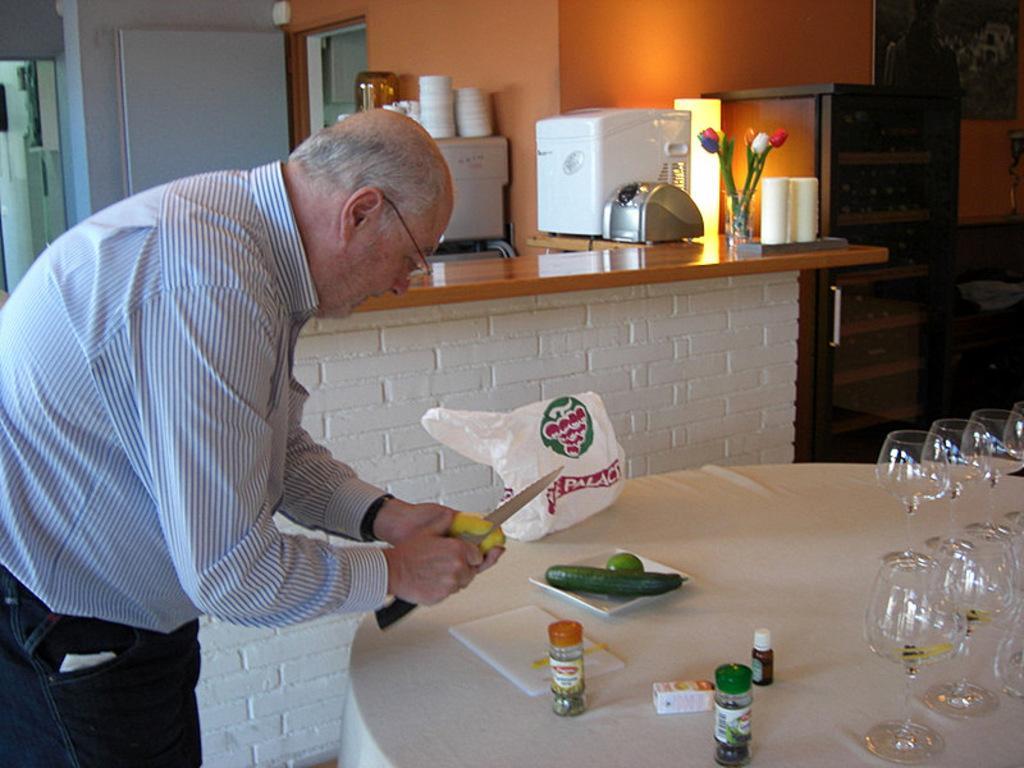In one or two sentences, can you explain what this image depicts? This picture might be taken inside the room. In this image, on the left side, we can see a man standing and cutting some fruits with his hands. On the right side, we can see a table, on that table, we can see a cloth which is in white color, polyethylene cover, plate with some vegetables and some bottles, wine glasses. In the background, we can see another table, on that table, we can see some electronic instrument, flower pot, flowers and a glass. On the right side, we can also see a box and a photo frame attached to a wall. In the background, we can see a door and a room. 